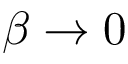Convert formula to latex. <formula><loc_0><loc_0><loc_500><loc_500>\beta \rightarrow 0</formula> 